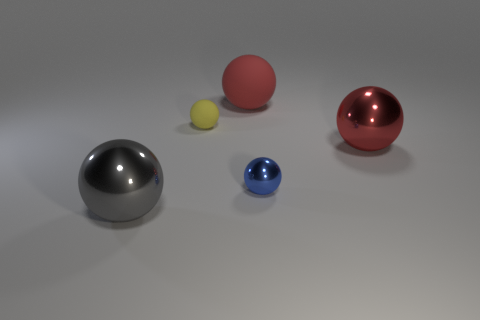Subtract all big gray shiny spheres. How many spheres are left? 4 Subtract all yellow balls. How many balls are left? 4 Subtract 2 balls. How many balls are left? 3 Subtract all brown spheres. Subtract all purple cylinders. How many spheres are left? 5 Add 1 large metallic balls. How many objects exist? 6 Subtract all blue shiny balls. Subtract all large gray metallic objects. How many objects are left? 3 Add 5 big red metallic spheres. How many big red metallic spheres are left? 6 Add 1 small metallic objects. How many small metallic objects exist? 2 Subtract 0 purple cylinders. How many objects are left? 5 